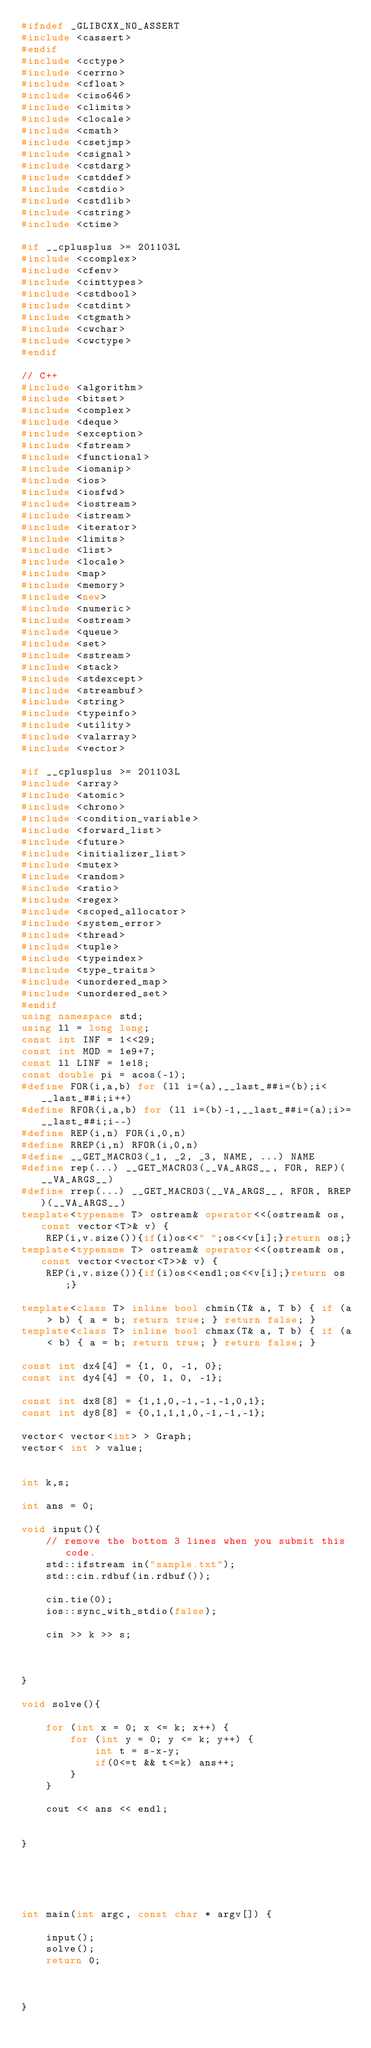Convert code to text. <code><loc_0><loc_0><loc_500><loc_500><_C++_>#ifndef _GLIBCXX_NO_ASSERT
#include <cassert>
#endif
#include <cctype>
#include <cerrno>
#include <cfloat>
#include <ciso646>
#include <climits>
#include <clocale>
#include <cmath>
#include <csetjmp>
#include <csignal>
#include <cstdarg>
#include <cstddef>
#include <cstdio>
#include <cstdlib>
#include <cstring>
#include <ctime>

#if __cplusplus >= 201103L
#include <ccomplex>
#include <cfenv>
#include <cinttypes>
#include <cstdbool>
#include <cstdint>
#include <ctgmath>
#include <cwchar>
#include <cwctype>
#endif

// C++
#include <algorithm>
#include <bitset>
#include <complex>
#include <deque>
#include <exception>
#include <fstream>
#include <functional>
#include <iomanip>
#include <ios>
#include <iosfwd>
#include <iostream>
#include <istream>
#include <iterator>
#include <limits>
#include <list>
#include <locale>
#include <map>
#include <memory>
#include <new>
#include <numeric>
#include <ostream>
#include <queue>
#include <set>
#include <sstream>
#include <stack>
#include <stdexcept>
#include <streambuf>
#include <string>
#include <typeinfo>
#include <utility>
#include <valarray>
#include <vector>

#if __cplusplus >= 201103L
#include <array>
#include <atomic>
#include <chrono>
#include <condition_variable>
#include <forward_list>
#include <future>
#include <initializer_list>
#include <mutex>
#include <random>
#include <ratio>
#include <regex>
#include <scoped_allocator>
#include <system_error>
#include <thread>
#include <tuple>
#include <typeindex>
#include <type_traits>
#include <unordered_map>
#include <unordered_set>
#endif
using namespace std;
using ll = long long;
const int INF = 1<<29;
const int MOD = 1e9+7;
const ll LINF = 1e18;
const double pi = acos(-1);
#define FOR(i,a,b) for (ll i=(a),__last_##i=(b);i<__last_##i;i++)
#define RFOR(i,a,b) for (ll i=(b)-1,__last_##i=(a);i>=__last_##i;i--)
#define REP(i,n) FOR(i,0,n)
#define RREP(i,n) RFOR(i,0,n)
#define __GET_MACRO3(_1, _2, _3, NAME, ...) NAME
#define rep(...) __GET_MACRO3(__VA_ARGS__, FOR, REP)(__VA_ARGS__)
#define rrep(...) __GET_MACRO3(__VA_ARGS__, RFOR, RREP)(__VA_ARGS__)
template<typename T> ostream& operator<<(ostream& os, const vector<T>& v) {
    REP(i,v.size()){if(i)os<<" ";os<<v[i];}return os;}
template<typename T> ostream& operator<<(ostream& os, const vector<vector<T>>& v) {
    REP(i,v.size()){if(i)os<<endl;os<<v[i];}return os;}

template<class T> inline bool chmin(T& a, T b) { if (a > b) { a = b; return true; } return false; }
template<class T> inline bool chmax(T& a, T b) { if (a < b) { a = b; return true; } return false; }

const int dx4[4] = {1, 0, -1, 0};
const int dy4[4] = {0, 1, 0, -1};

const int dx8[8] = {1,1,0,-1,-1,-1,0,1};
const int dy8[8] = {0,1,1,1,0,-1,-1,-1};

vector< vector<int> > Graph;
vector< int > value;


int k,s;

int ans = 0;

void input(){
    // remove the bottom 3 lines when you submit this code.
    std::ifstream in("sample.txt");
    std::cin.rdbuf(in.rdbuf());

    cin.tie(0);
    ios::sync_with_stdio(false);
    
    cin >> k >> s;
    
    
    
}

void solve(){
    
    for (int x = 0; x <= k; x++) {
        for (int y = 0; y <= k; y++) {
            int t = s-x-y;
            if(0<=t && t<=k) ans++;
        }
    }
    
    cout << ans << endl;
    
    
}





int main(int argc, const char * argv[]) {
    
    input();
    solve();
    return 0;
    
  
    
}

</code> 